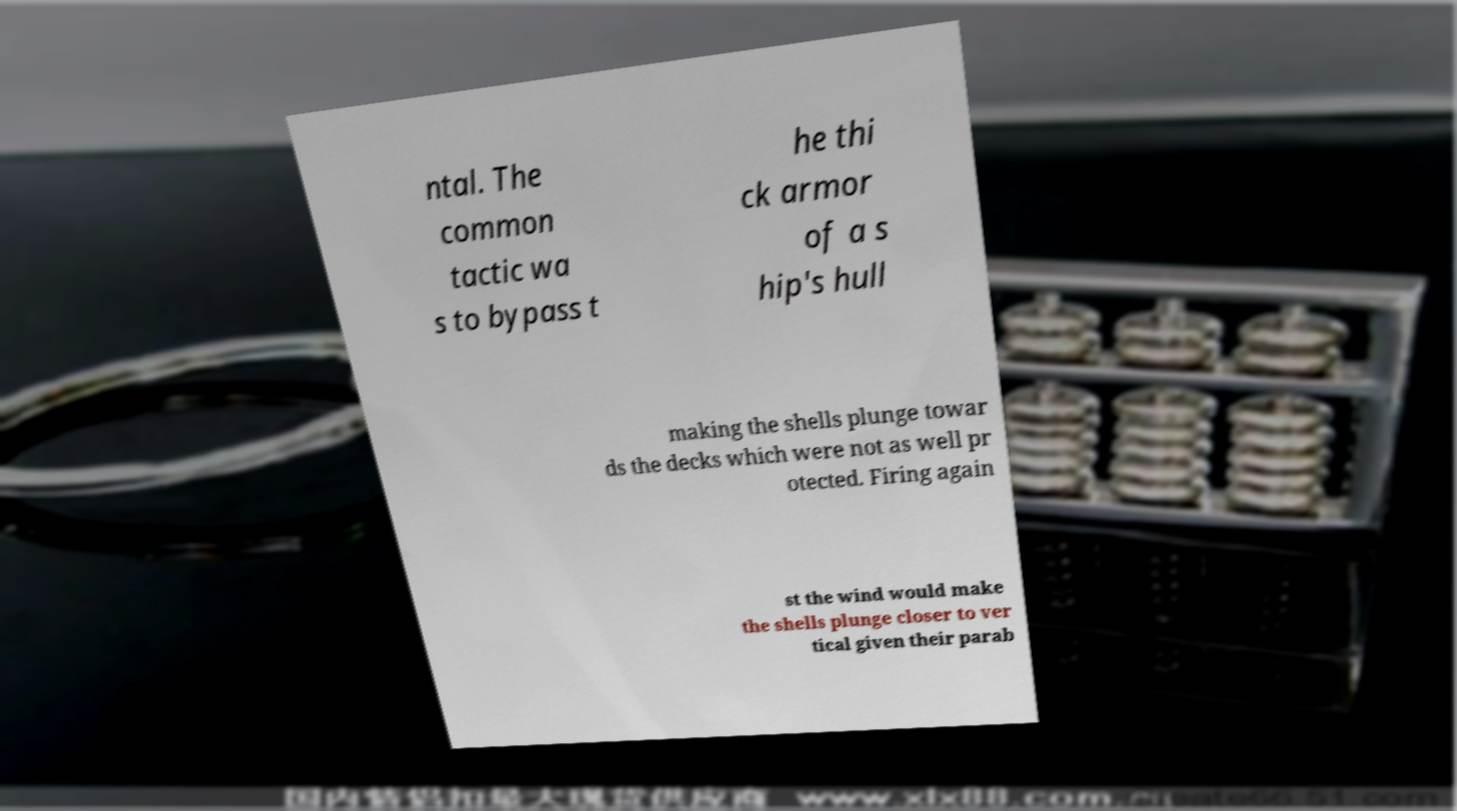Please identify and transcribe the text found in this image. ntal. The common tactic wa s to bypass t he thi ck armor of a s hip's hull making the shells plunge towar ds the decks which were not as well pr otected. Firing again st the wind would make the shells plunge closer to ver tical given their parab 